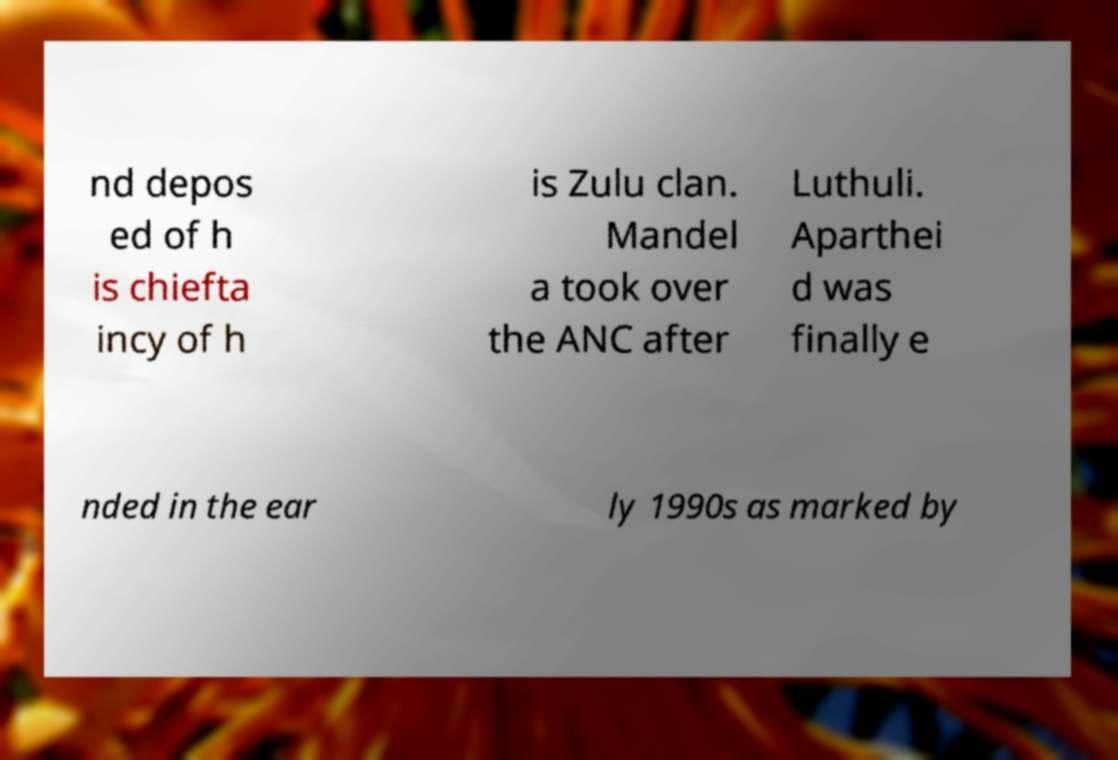Please identify and transcribe the text found in this image. nd depos ed of h is chiefta incy of h is Zulu clan. Mandel a took over the ANC after Luthuli. Aparthei d was finally e nded in the ear ly 1990s as marked by 